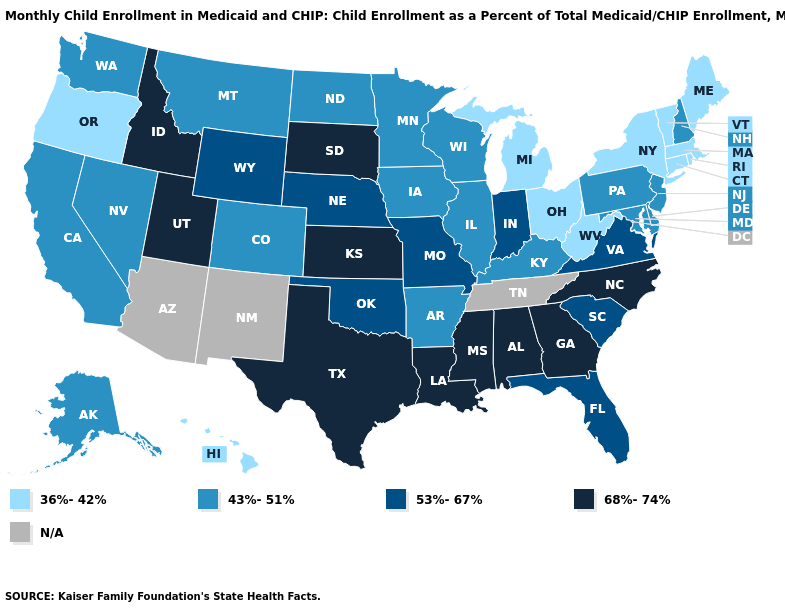Is the legend a continuous bar?
Quick response, please. No. Which states have the lowest value in the MidWest?
Keep it brief. Michigan, Ohio. Name the states that have a value in the range 36%-42%?
Write a very short answer. Connecticut, Hawaii, Maine, Massachusetts, Michigan, New York, Ohio, Oregon, Rhode Island, Vermont, West Virginia. How many symbols are there in the legend?
Write a very short answer. 5. How many symbols are there in the legend?
Give a very brief answer. 5. Name the states that have a value in the range N/A?
Short answer required. Arizona, New Mexico, Tennessee. What is the highest value in the Northeast ?
Give a very brief answer. 43%-51%. What is the lowest value in the West?
Keep it brief. 36%-42%. Name the states that have a value in the range 53%-67%?
Write a very short answer. Florida, Indiana, Missouri, Nebraska, Oklahoma, South Carolina, Virginia, Wyoming. Among the states that border Indiana , does Michigan have the highest value?
Short answer required. No. Name the states that have a value in the range 36%-42%?
Be succinct. Connecticut, Hawaii, Maine, Massachusetts, Michigan, New York, Ohio, Oregon, Rhode Island, Vermont, West Virginia. Does Connecticut have the highest value in the USA?
Short answer required. No. What is the highest value in states that border Montana?
Keep it brief. 68%-74%. What is the value of Indiana?
Short answer required. 53%-67%. 